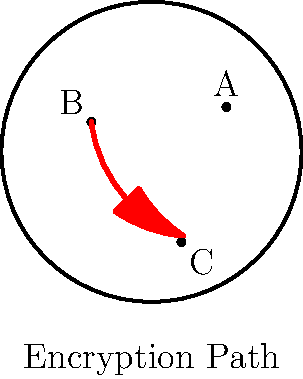In the context of visualizing data encryption in hyperbolic space, consider the hyperbolic plane represented by the Poincaré disk model shown above. If data is encrypted along the geodesic path from point A to point C via point B, what is the hyperbolic distance of this encryption path? To find the hyperbolic distance of the encryption path, we'll follow these steps:

1. In the Poincaré disk model, geodesics are represented by arcs of circles perpendicular to the boundary circle or diameters of the boundary circle.

2. The encryption path follows the arc ABC, which is a geodesic in hyperbolic space.

3. The hyperbolic distance between two points $P_1(x_1, y_1)$ and $P_2(x_2, y_2)$ in the Poincaré disk model is given by:

   $$d_H(P_1, P_2) = \text{arcosh}\left(1 + \frac{2(x_1 - x_2)^2 + 2(y_1 - y_2)^2}{(1 - x_1^2 - y_1^2)(1 - x_2^2 - y_2^2)}\right)$$

4. We need to calculate this distance for segments AB and BC, then sum them:

   $d_{total} = d_H(A, B) + d_H(B, C)$

5. Given the coordinates:
   A(0.5, 0.3)
   B(-0.4, 0.2)
   C(0.2, -0.6)

6. Calculating $d_H(A, B)$:
   $$d_H(A, B) = \text{arcosh}\left(1 + \frac{2(0.5 - (-0.4))^2 + 2(0.3 - 0.2)^2}{(1 - 0.5^2 - 0.3^2)(1 - (-0.4)^2 - 0.2^2)}\right) \approx 1.358$$

7. Calculating $d_H(B, C)$:
   $$d_H(B, C) = \text{arcosh}\left(1 + \frac{2(-0.4 - 0.2)^2 + 2(0.2 - (-0.6))^2}{(1 - (-0.4)^2 - 0.2^2)(1 - 0.2^2 - (-0.6)^2)}\right) \approx 1.431$$

8. The total hyperbolic distance is:
   $d_{total} = 1.358 + 1.431 \approx 2.789$
Answer: $2.789$ (hyperbolic units) 